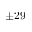Convert formula to latex. <formula><loc_0><loc_0><loc_500><loc_500>\pm 2 9</formula> 